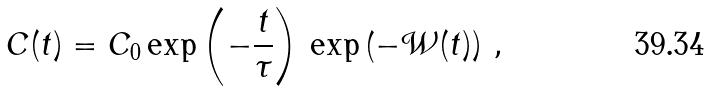<formula> <loc_0><loc_0><loc_500><loc_500>C ( t ) = C _ { 0 } \exp \left ( - \frac { t } { \tau } \right ) \, \exp \left ( - \mathcal { W } ( t ) \right ) \, ,</formula> 